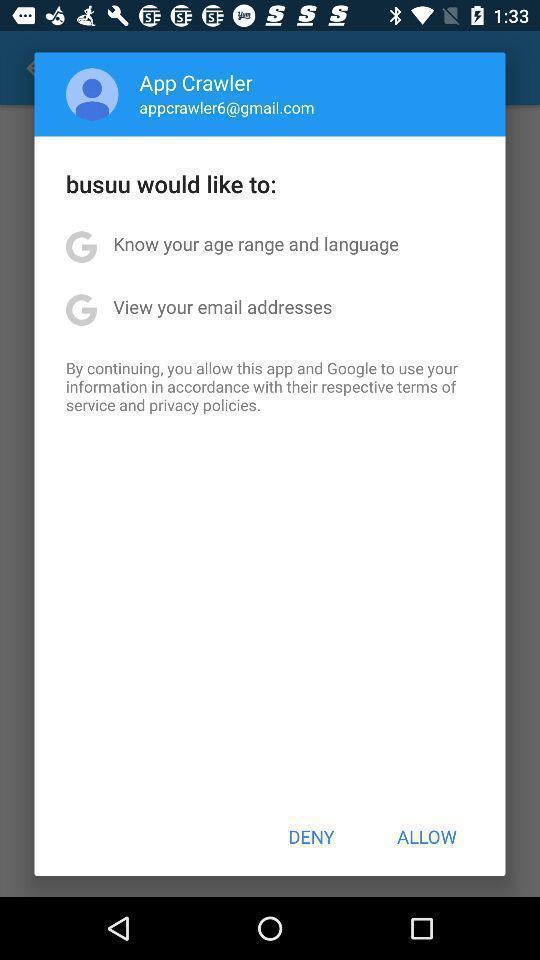Explain what's happening in this screen capture. Pop-up asking to allow the app to use information. 